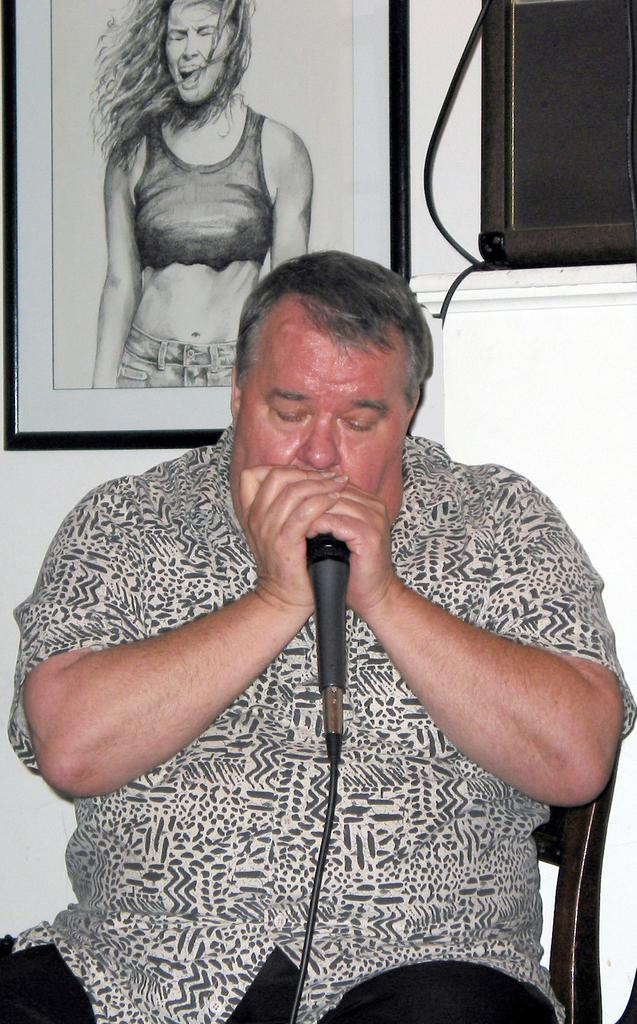What is the man in the image doing? The man is sitting on a chair and holding a microphone. What can be seen behind the man? There is a wall behind the man. Is there anything on the wall? Yes, there is a frame on the wall. What type of cakes are being served at the party in the image? There is no party or cakes present in the image; it only features a man sitting on a chair holding a microphone. What channel is the man broadcasting on in the image? There is no indication of a broadcast or channel in the image; it only shows a man sitting on a chair holding a microphone. 